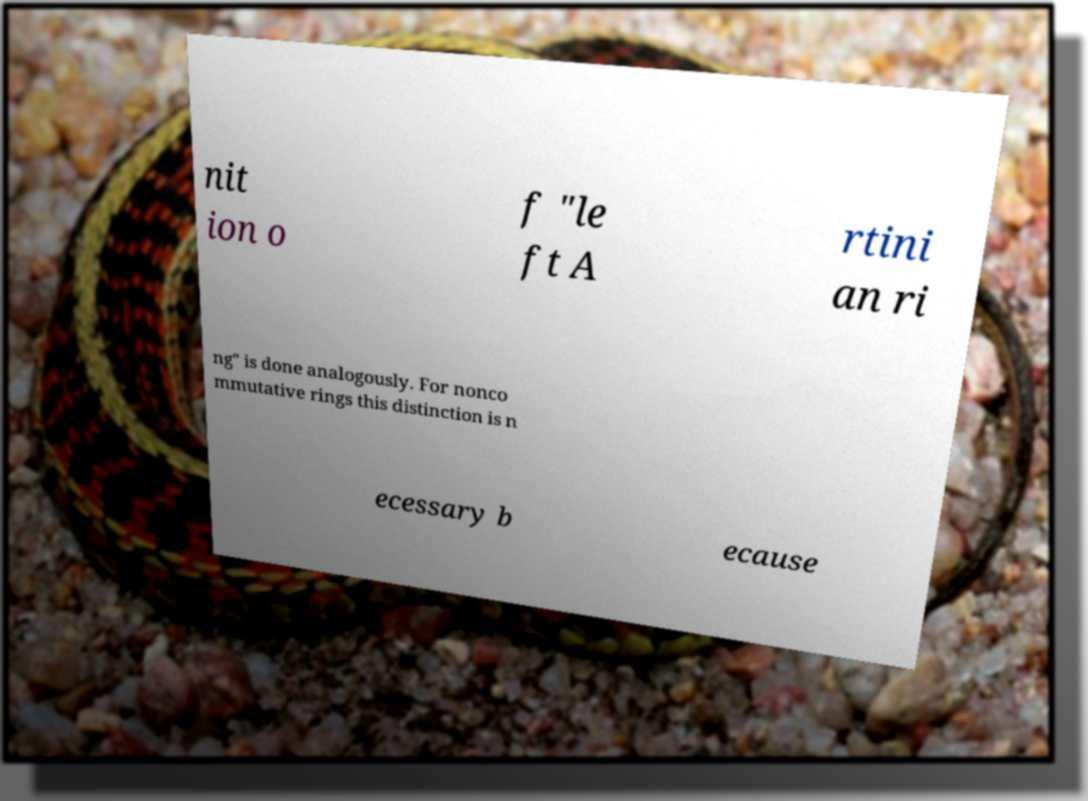Please identify and transcribe the text found in this image. nit ion o f "le ft A rtini an ri ng" is done analogously. For nonco mmutative rings this distinction is n ecessary b ecause 